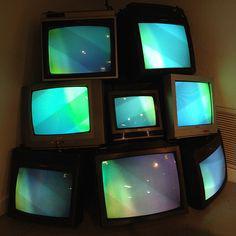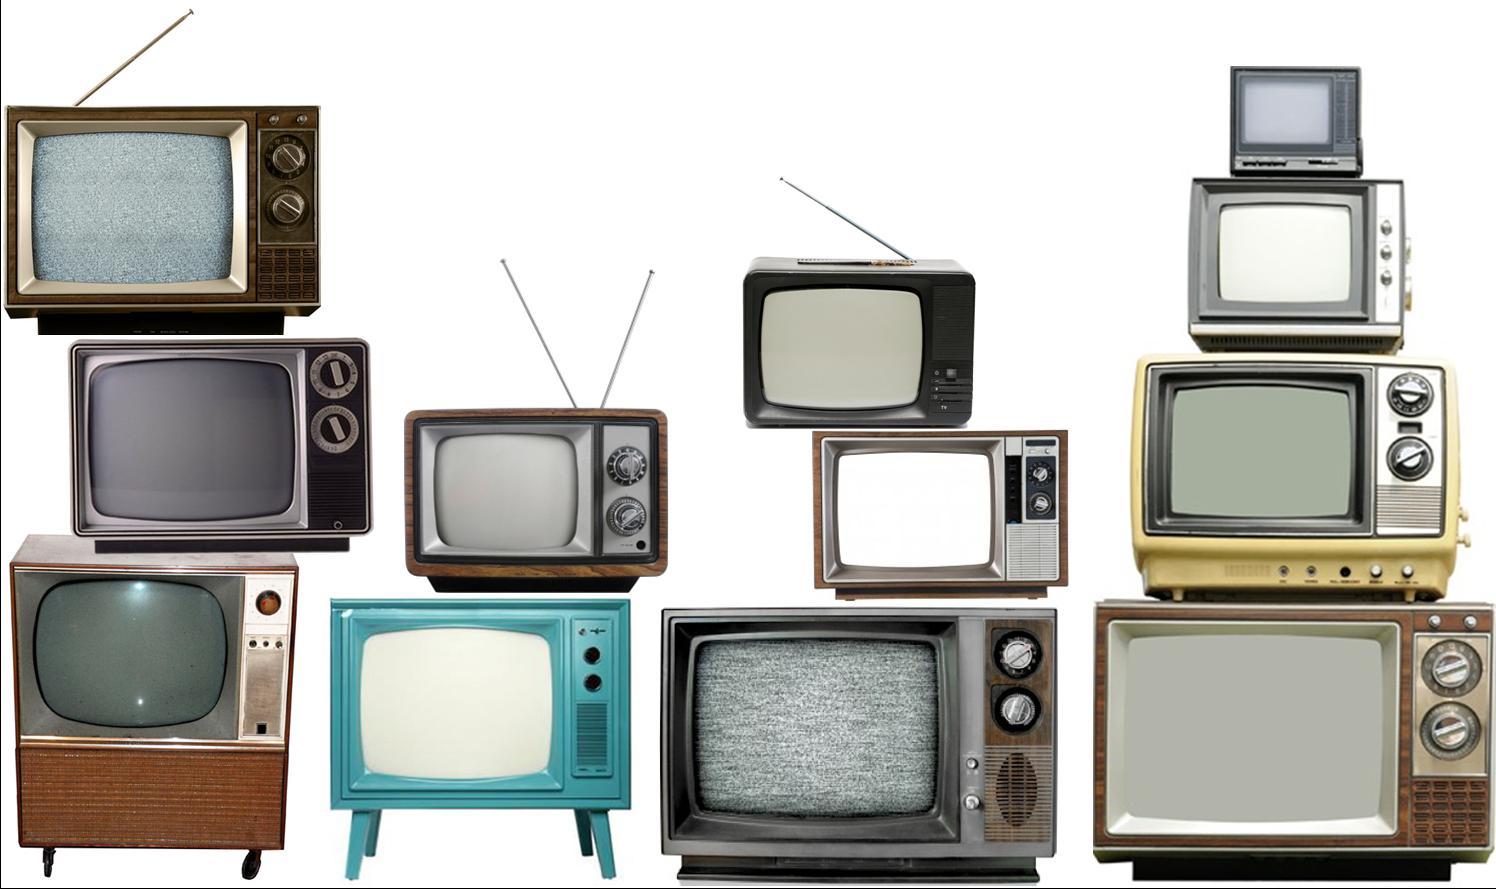The first image is the image on the left, the second image is the image on the right. For the images displayed, is the sentence "In one image there are television sets being displayed as art arranged in a column." factually correct? Answer yes or no. No. The first image is the image on the left, the second image is the image on the right. Given the left and right images, does the statement "One of the images has less than ten TVs." hold true? Answer yes or no. Yes. 